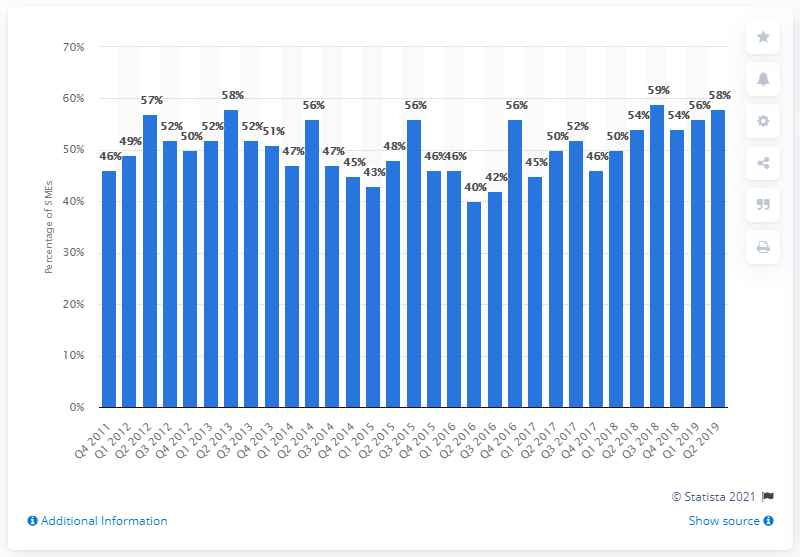Specify some key components in this picture. A survey of small and medium-sized enterprises (SMEs) in the real estate sector found that 59% of them planned to expand in the following 12 months. 